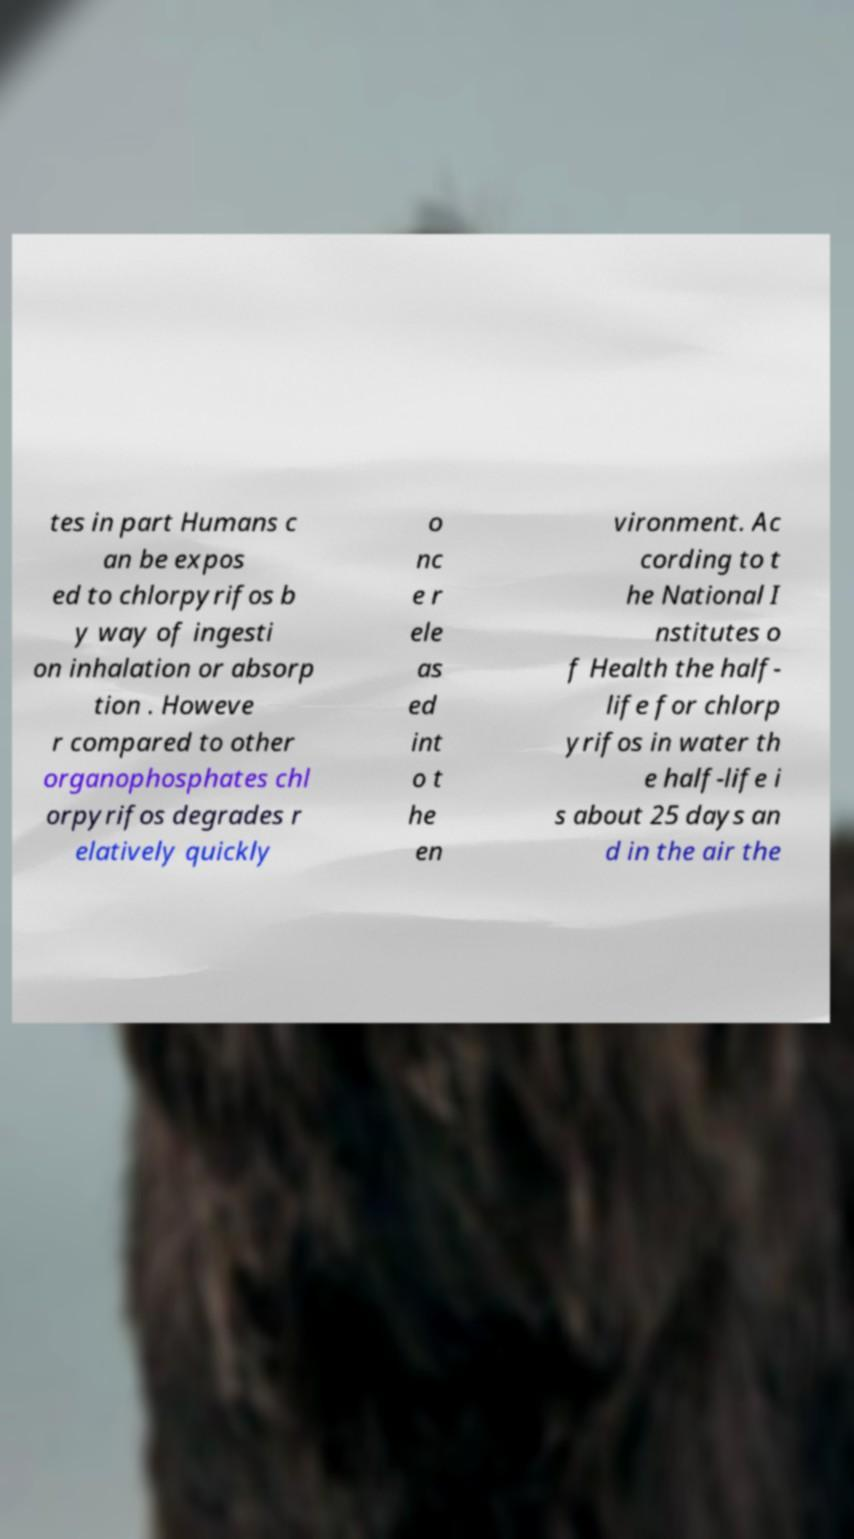There's text embedded in this image that I need extracted. Can you transcribe it verbatim? tes in part Humans c an be expos ed to chlorpyrifos b y way of ingesti on inhalation or absorp tion . Howeve r compared to other organophosphates chl orpyrifos degrades r elatively quickly o nc e r ele as ed int o t he en vironment. Ac cording to t he National I nstitutes o f Health the half- life for chlorp yrifos in water th e half-life i s about 25 days an d in the air the 